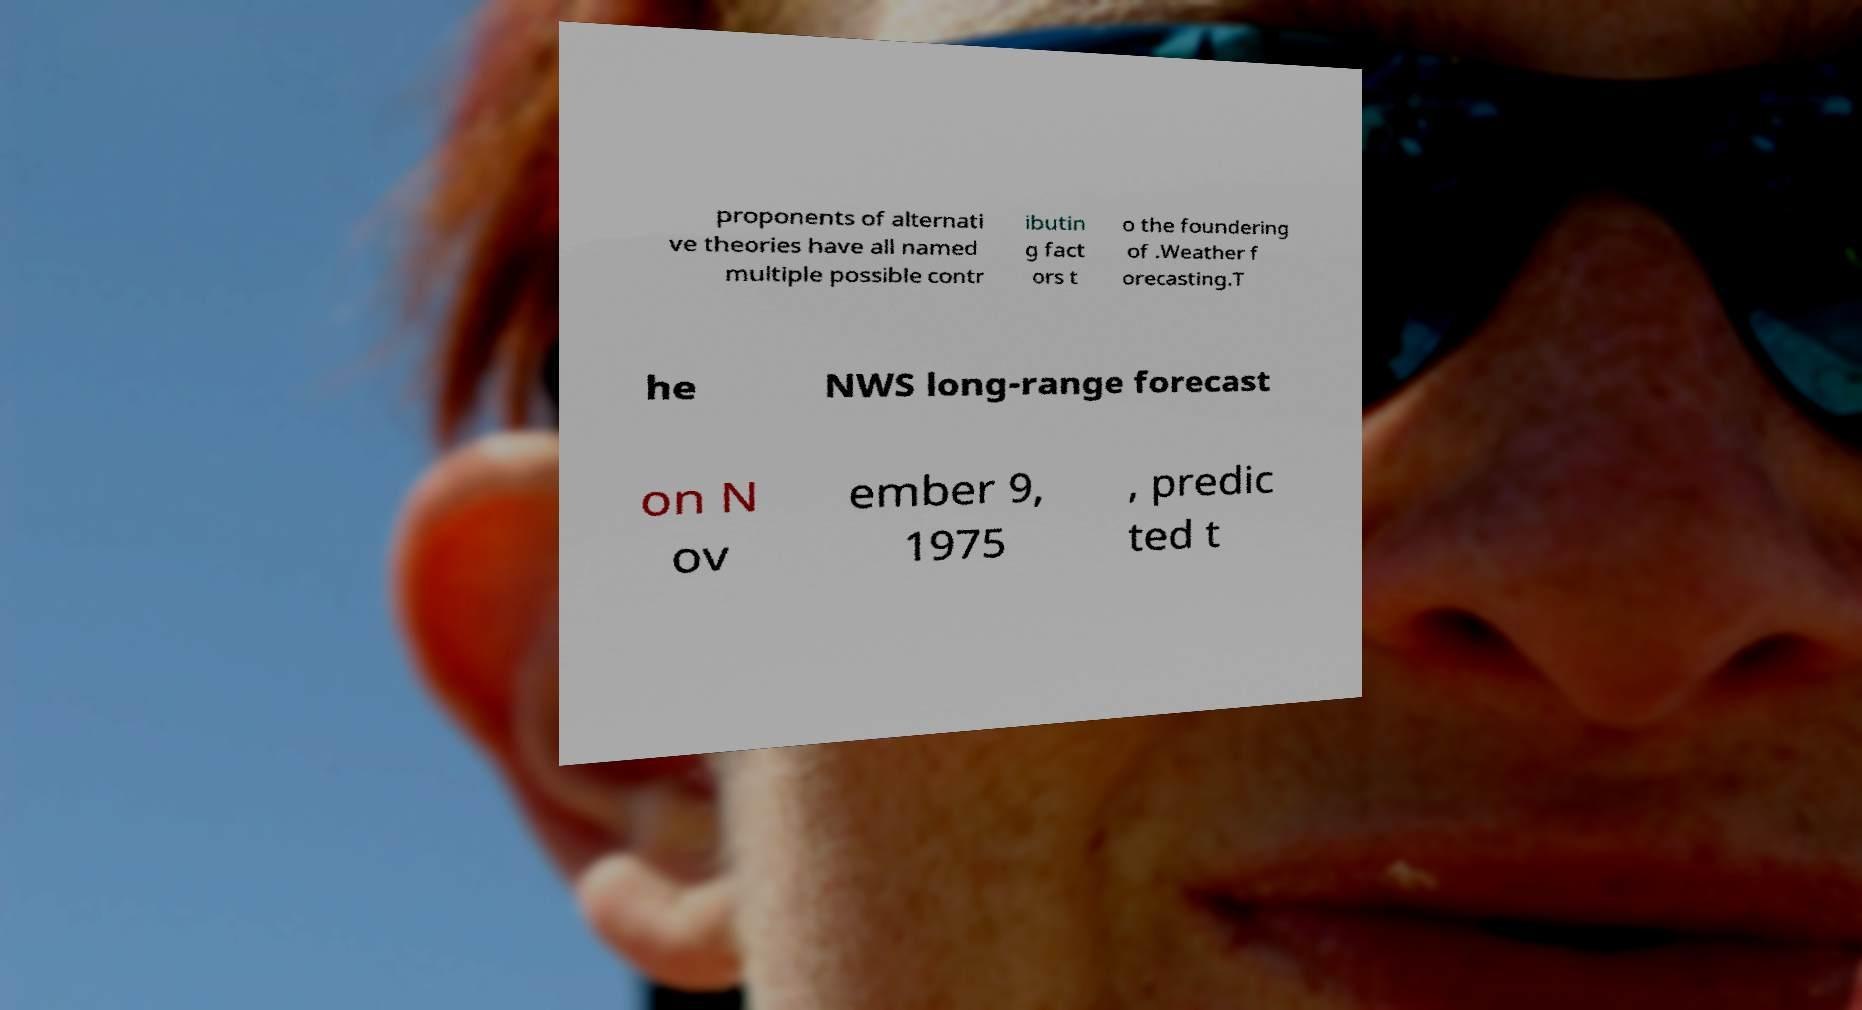For documentation purposes, I need the text within this image transcribed. Could you provide that? proponents of alternati ve theories have all named multiple possible contr ibutin g fact ors t o the foundering of .Weather f orecasting.T he NWS long-range forecast on N ov ember 9, 1975 , predic ted t 